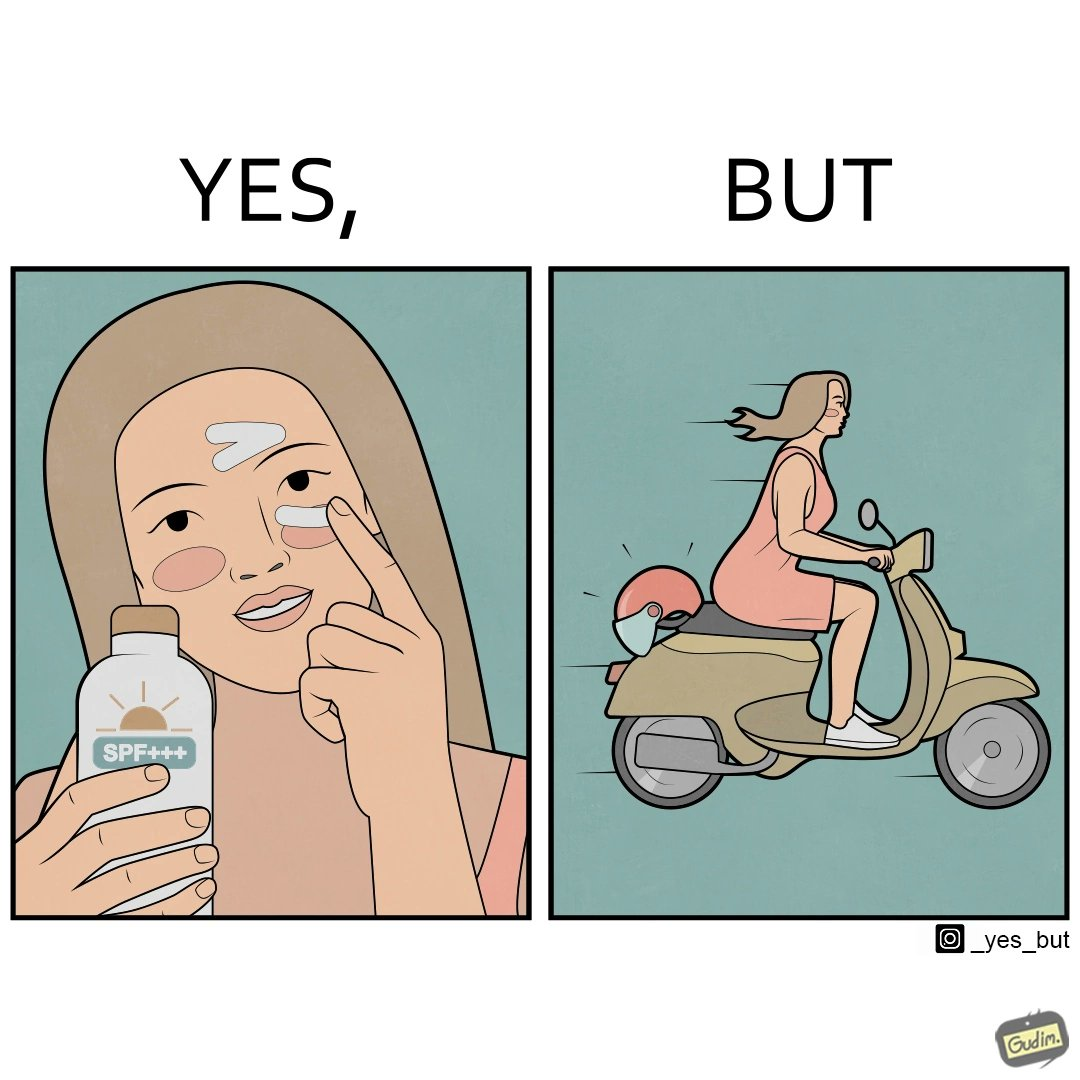Is this image satirical or non-satirical? Yes, this image is satirical. 